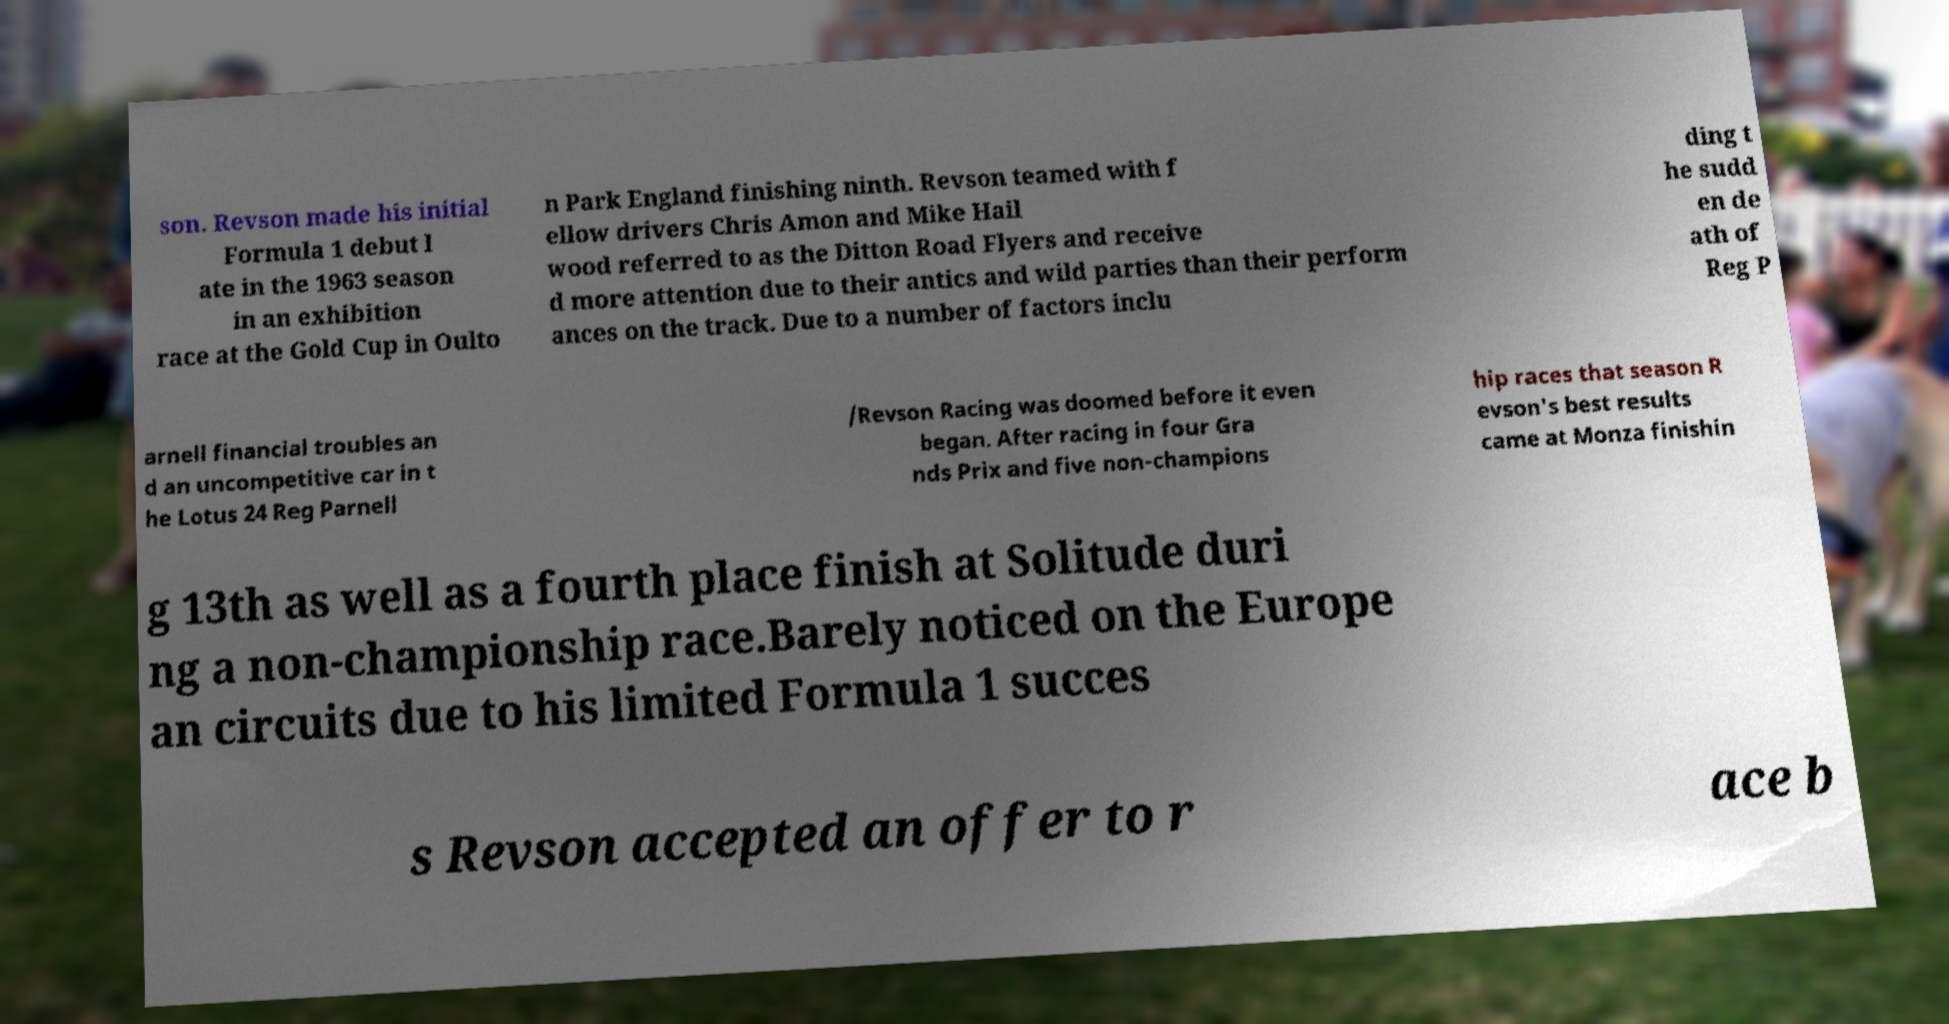Can you accurately transcribe the text from the provided image for me? son. Revson made his initial Formula 1 debut l ate in the 1963 season in an exhibition race at the Gold Cup in Oulto n Park England finishing ninth. Revson teamed with f ellow drivers Chris Amon and Mike Hail wood referred to as the Ditton Road Flyers and receive d more attention due to their antics and wild parties than their perform ances on the track. Due to a number of factors inclu ding t he sudd en de ath of Reg P arnell financial troubles an d an uncompetitive car in t he Lotus 24 Reg Parnell /Revson Racing was doomed before it even began. After racing in four Gra nds Prix and five non-champions hip races that season R evson's best results came at Monza finishin g 13th as well as a fourth place finish at Solitude duri ng a non-championship race.Barely noticed on the Europe an circuits due to his limited Formula 1 succes s Revson accepted an offer to r ace b 